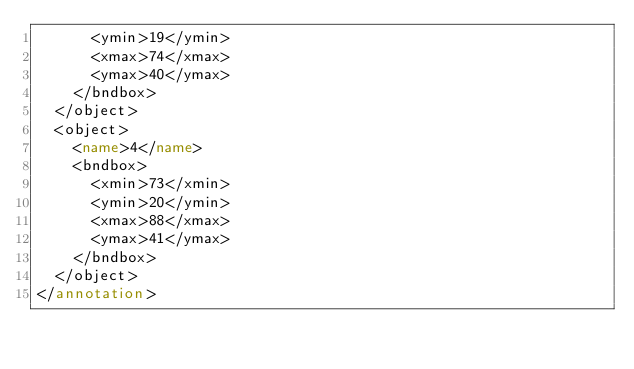Convert code to text. <code><loc_0><loc_0><loc_500><loc_500><_XML_>      <ymin>19</ymin>
      <xmax>74</xmax>
      <ymax>40</ymax>
    </bndbox>
  </object>
  <object>
    <name>4</name>
    <bndbox>
      <xmin>73</xmin>
      <ymin>20</ymin>
      <xmax>88</xmax>
      <ymax>41</ymax>
    </bndbox>
  </object>
</annotation>
</code> 